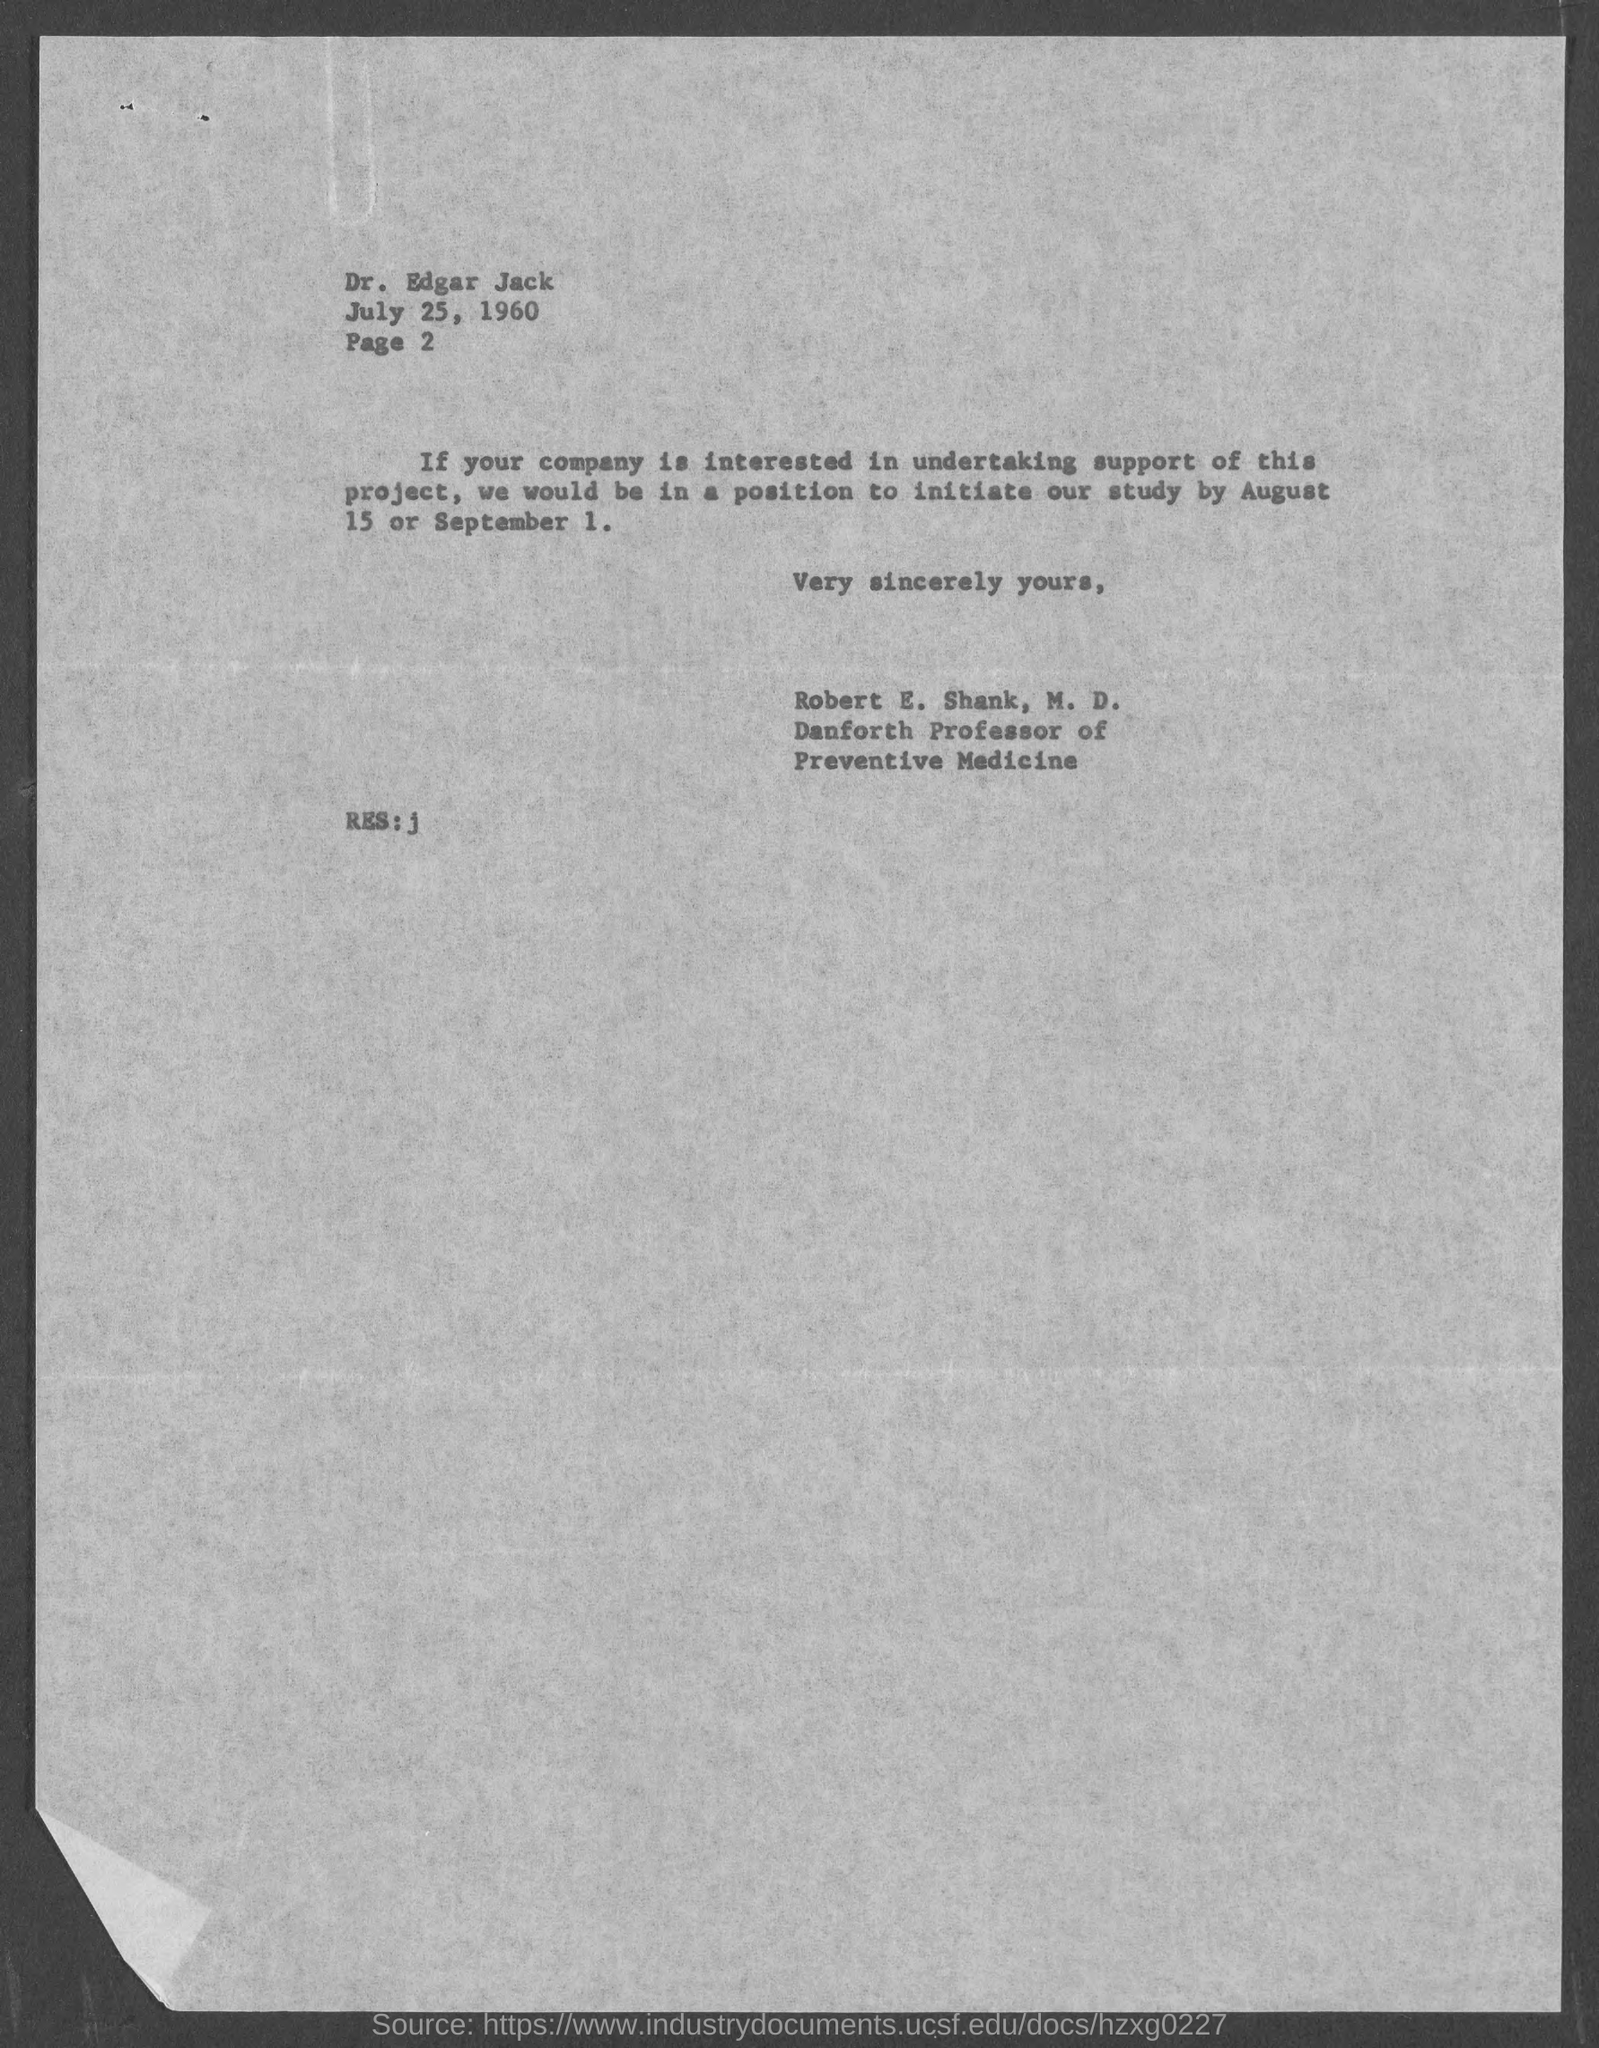List a handful of essential elements in this visual. This study can be initiated on August 15 or September 1. The page number mentioned under Dr. Edgar Jack is 2. The letter was written by Robert E. Shank, M.D. Robert E. Shank, M.D., is the Danforth Professor of Preventive Medicine. This letter is addressed to Dr. Edgar Jack. 